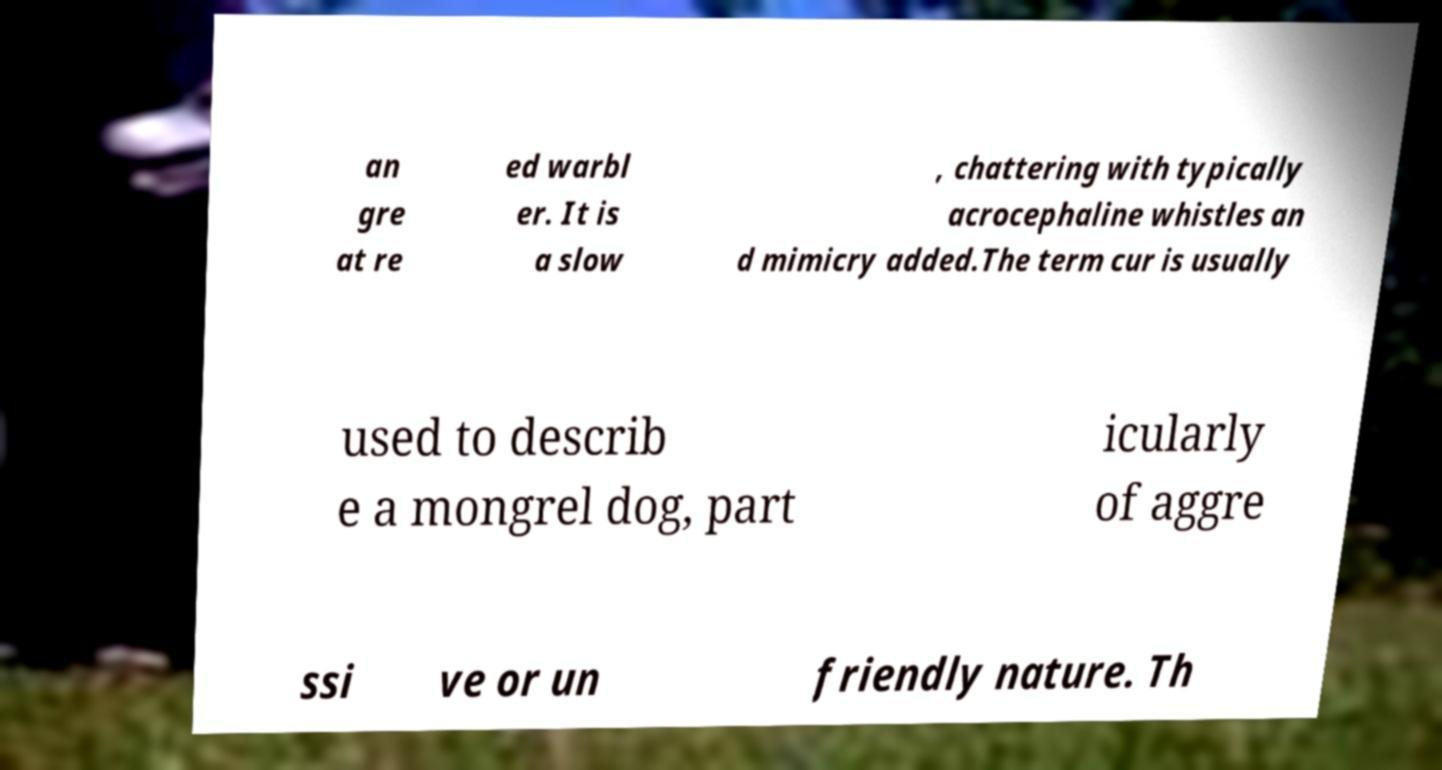I need the written content from this picture converted into text. Can you do that? an gre at re ed warbl er. It is a slow , chattering with typically acrocephaline whistles an d mimicry added.The term cur is usually used to describ e a mongrel dog, part icularly of aggre ssi ve or un friendly nature. Th 